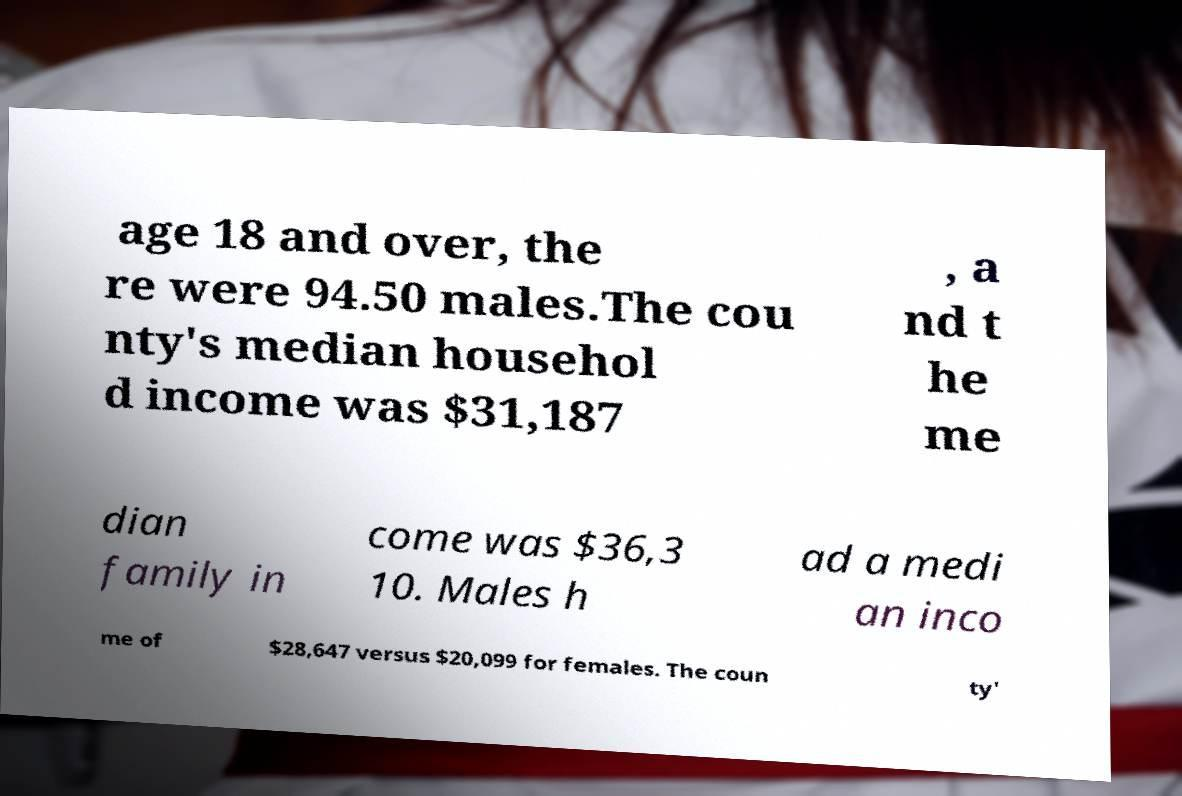Please read and relay the text visible in this image. What does it say? age 18 and over, the re were 94.50 males.The cou nty's median househol d income was $31,187 , a nd t he me dian family in come was $36,3 10. Males h ad a medi an inco me of $28,647 versus $20,099 for females. The coun ty' 